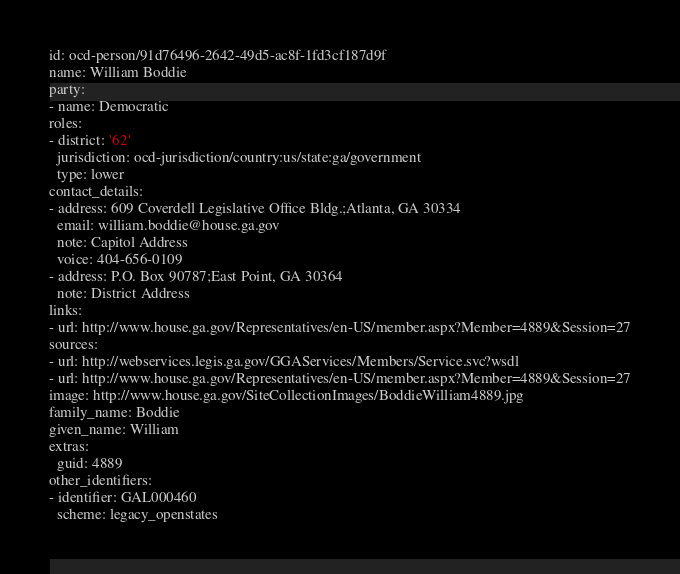Convert code to text. <code><loc_0><loc_0><loc_500><loc_500><_YAML_>id: ocd-person/91d76496-2642-49d5-ac8f-1fd3cf187d9f
name: William Boddie
party:
- name: Democratic
roles:
- district: '62'
  jurisdiction: ocd-jurisdiction/country:us/state:ga/government
  type: lower
contact_details:
- address: 609 Coverdell Legislative Office Bldg.;Atlanta, GA 30334
  email: william.boddie@house.ga.gov
  note: Capitol Address
  voice: 404-656-0109
- address: P.O. Box 90787;East Point, GA 30364
  note: District Address
links:
- url: http://www.house.ga.gov/Representatives/en-US/member.aspx?Member=4889&Session=27
sources:
- url: http://webservices.legis.ga.gov/GGAServices/Members/Service.svc?wsdl
- url: http://www.house.ga.gov/Representatives/en-US/member.aspx?Member=4889&Session=27
image: http://www.house.ga.gov/SiteCollectionImages/BoddieWilliam4889.jpg
family_name: Boddie
given_name: William
extras:
  guid: 4889
other_identifiers:
- identifier: GAL000460
  scheme: legacy_openstates
</code> 